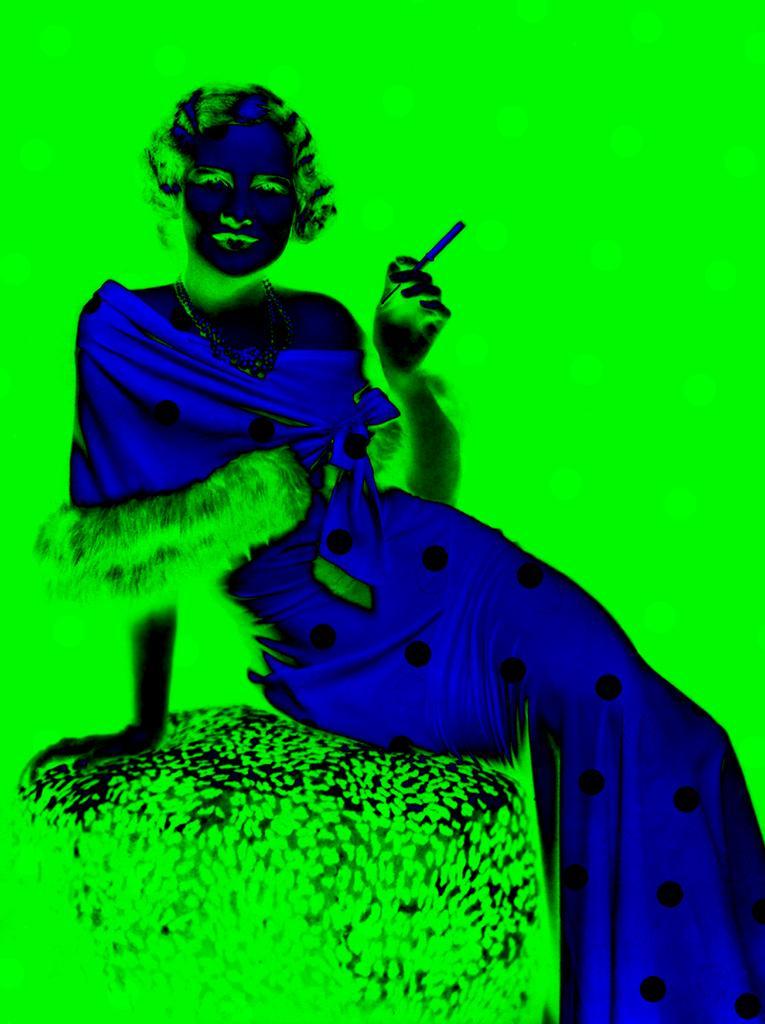How would you summarize this image in a sentence or two? This is an edited image. In this image I can see the person with the dress and holding something. I can see the person sitting on an object. And there is a green color background. 